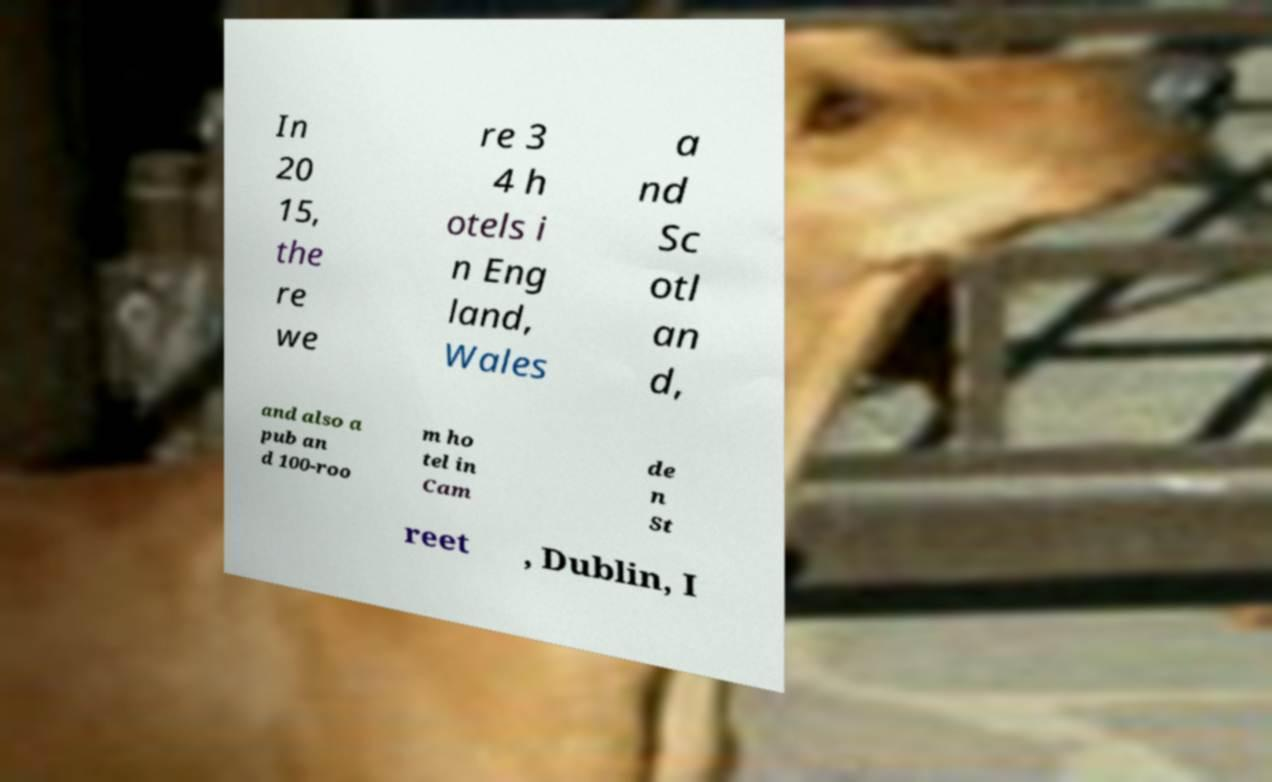What messages or text are displayed in this image? I need them in a readable, typed format. In 20 15, the re we re 3 4 h otels i n Eng land, Wales a nd Sc otl an d, and also a pub an d 100-roo m ho tel in Cam de n St reet , Dublin, I 